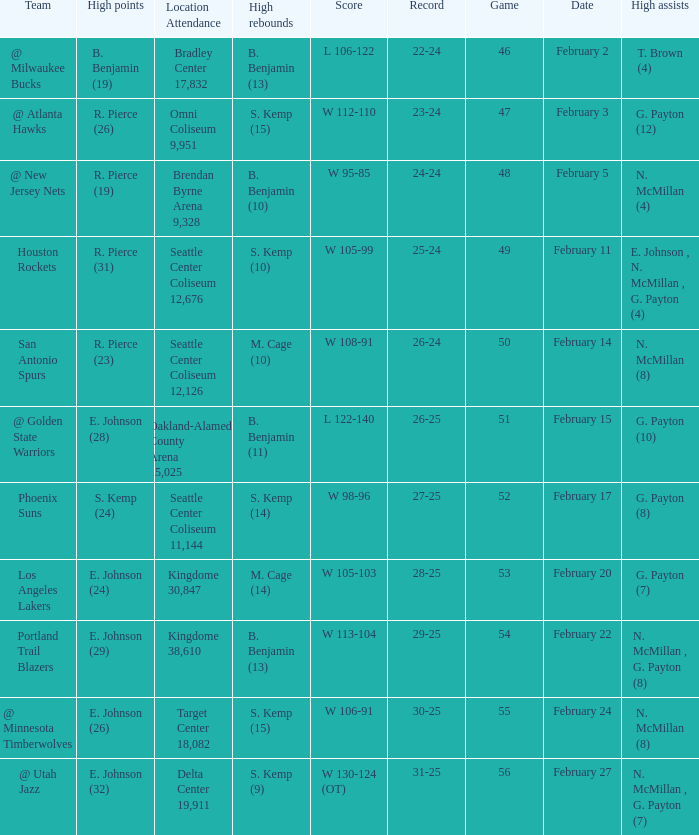Which game had a score of w 95-85? 48.0. 